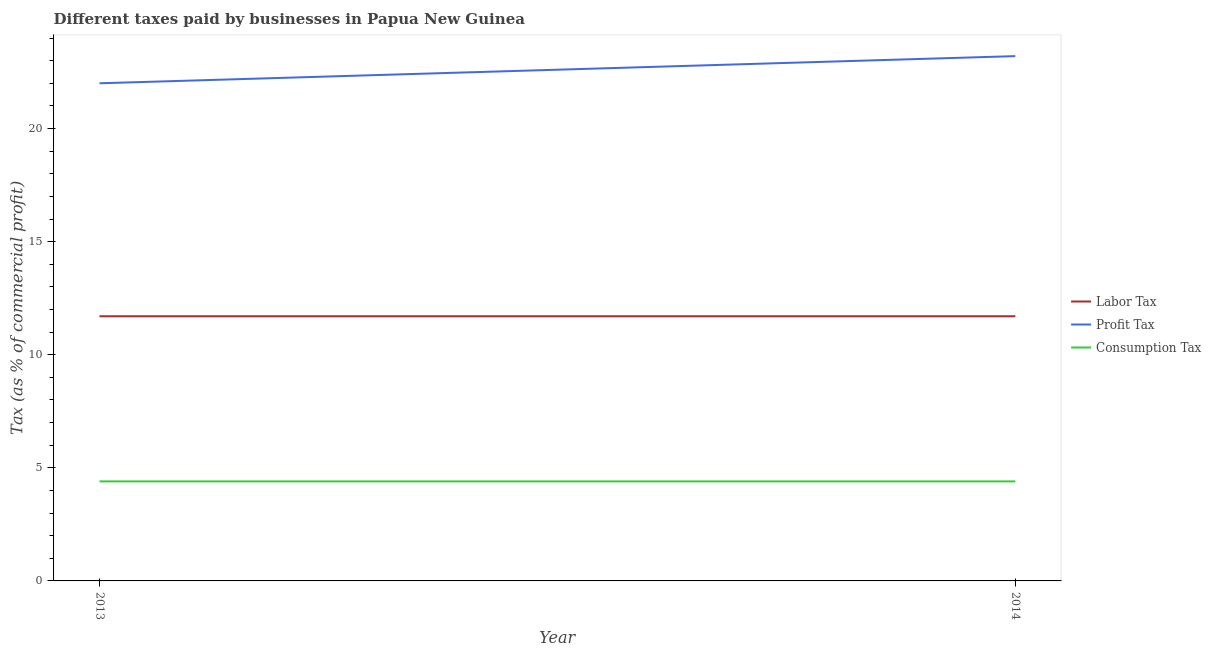How many different coloured lines are there?
Offer a very short reply. 3. Is the number of lines equal to the number of legend labels?
Keep it short and to the point. Yes. Across all years, what is the minimum percentage of consumption tax?
Ensure brevity in your answer.  4.4. What is the total percentage of consumption tax in the graph?
Offer a very short reply. 8.8. What is the difference between the percentage of labor tax in 2013 and that in 2014?
Your response must be concise. 0. What is the average percentage of profit tax per year?
Provide a short and direct response. 22.6. In the year 2013, what is the difference between the percentage of consumption tax and percentage of profit tax?
Give a very brief answer. -17.6. In how many years, is the percentage of profit tax greater than 12 %?
Your answer should be very brief. 2. What is the ratio of the percentage of profit tax in 2013 to that in 2014?
Give a very brief answer. 0.95. Is the percentage of profit tax in 2013 less than that in 2014?
Provide a succinct answer. Yes. Is it the case that in every year, the sum of the percentage of labor tax and percentage of profit tax is greater than the percentage of consumption tax?
Keep it short and to the point. Yes. Is the percentage of profit tax strictly less than the percentage of consumption tax over the years?
Offer a very short reply. No. How many lines are there?
Offer a very short reply. 3. How many years are there in the graph?
Your response must be concise. 2. Are the values on the major ticks of Y-axis written in scientific E-notation?
Provide a succinct answer. No. Where does the legend appear in the graph?
Your answer should be compact. Center right. How many legend labels are there?
Provide a succinct answer. 3. What is the title of the graph?
Your answer should be compact. Different taxes paid by businesses in Papua New Guinea. What is the label or title of the Y-axis?
Your answer should be compact. Tax (as % of commercial profit). What is the Tax (as % of commercial profit) in Labor Tax in 2013?
Provide a short and direct response. 11.7. What is the Tax (as % of commercial profit) in Profit Tax in 2013?
Ensure brevity in your answer.  22. What is the Tax (as % of commercial profit) in Consumption Tax in 2013?
Provide a succinct answer. 4.4. What is the Tax (as % of commercial profit) in Labor Tax in 2014?
Offer a terse response. 11.7. What is the Tax (as % of commercial profit) of Profit Tax in 2014?
Provide a short and direct response. 23.2. Across all years, what is the maximum Tax (as % of commercial profit) of Labor Tax?
Your answer should be compact. 11.7. Across all years, what is the maximum Tax (as % of commercial profit) in Profit Tax?
Your answer should be compact. 23.2. Across all years, what is the maximum Tax (as % of commercial profit) in Consumption Tax?
Your answer should be very brief. 4.4. Across all years, what is the minimum Tax (as % of commercial profit) of Profit Tax?
Your response must be concise. 22. What is the total Tax (as % of commercial profit) in Labor Tax in the graph?
Give a very brief answer. 23.4. What is the total Tax (as % of commercial profit) of Profit Tax in the graph?
Offer a terse response. 45.2. What is the total Tax (as % of commercial profit) of Consumption Tax in the graph?
Your answer should be very brief. 8.8. What is the difference between the Tax (as % of commercial profit) of Labor Tax in 2013 and that in 2014?
Ensure brevity in your answer.  0. What is the difference between the Tax (as % of commercial profit) of Consumption Tax in 2013 and that in 2014?
Ensure brevity in your answer.  0. What is the difference between the Tax (as % of commercial profit) of Labor Tax in 2013 and the Tax (as % of commercial profit) of Consumption Tax in 2014?
Keep it short and to the point. 7.3. What is the average Tax (as % of commercial profit) of Labor Tax per year?
Keep it short and to the point. 11.7. What is the average Tax (as % of commercial profit) of Profit Tax per year?
Provide a short and direct response. 22.6. In the year 2014, what is the difference between the Tax (as % of commercial profit) in Labor Tax and Tax (as % of commercial profit) in Consumption Tax?
Ensure brevity in your answer.  7.3. What is the ratio of the Tax (as % of commercial profit) in Profit Tax in 2013 to that in 2014?
Provide a short and direct response. 0.95. What is the ratio of the Tax (as % of commercial profit) of Consumption Tax in 2013 to that in 2014?
Offer a very short reply. 1. What is the difference between the highest and the second highest Tax (as % of commercial profit) in Labor Tax?
Offer a terse response. 0. What is the difference between the highest and the lowest Tax (as % of commercial profit) of Labor Tax?
Offer a very short reply. 0. 